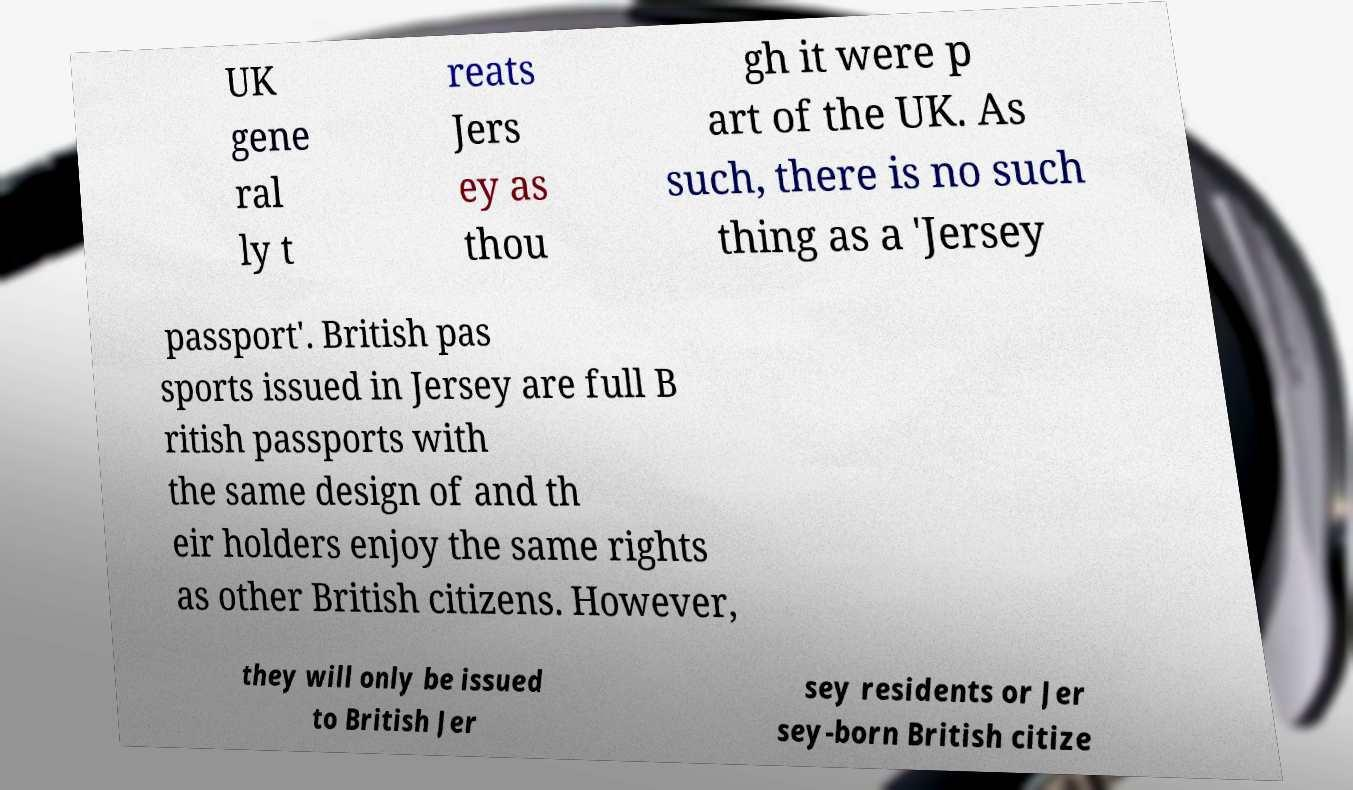Could you extract and type out the text from this image? UK gene ral ly t reats Jers ey as thou gh it were p art of the UK. As such, there is no such thing as a 'Jersey passport'. British pas sports issued in Jersey are full B ritish passports with the same design of and th eir holders enjoy the same rights as other British citizens. However, they will only be issued to British Jer sey residents or Jer sey-born British citize 